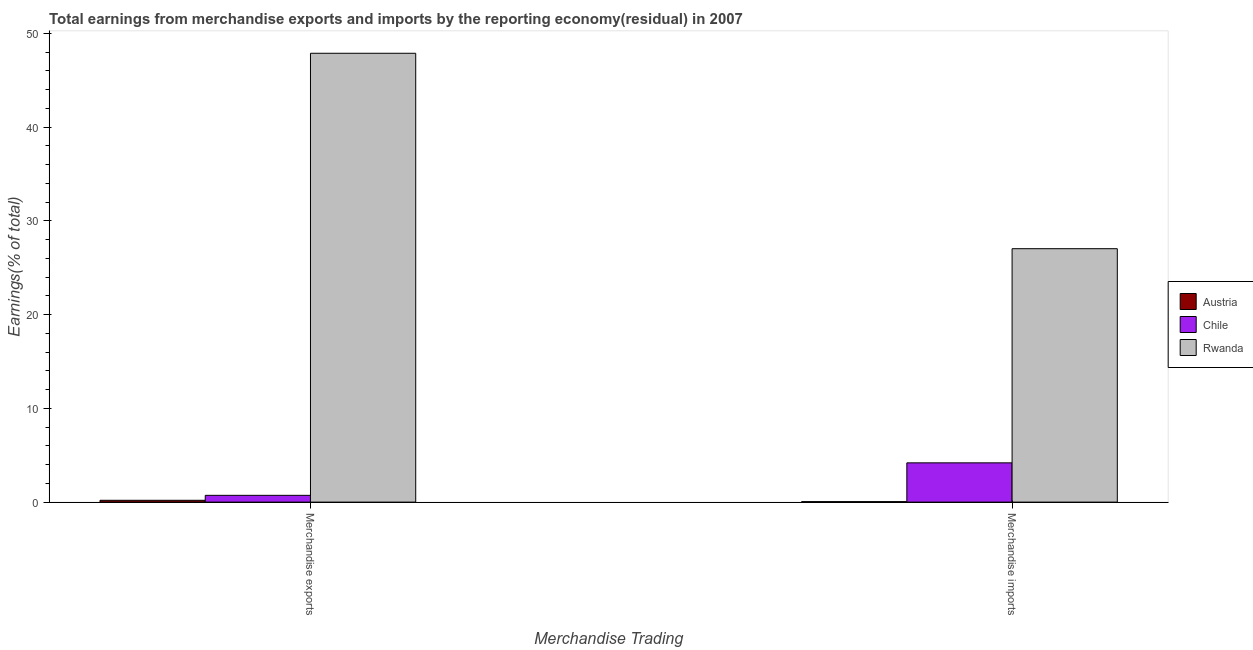How many bars are there on the 2nd tick from the right?
Your answer should be compact. 3. What is the earnings from merchandise imports in Chile?
Offer a terse response. 4.19. Across all countries, what is the maximum earnings from merchandise exports?
Ensure brevity in your answer.  47.87. Across all countries, what is the minimum earnings from merchandise exports?
Keep it short and to the point. 0.2. In which country was the earnings from merchandise imports maximum?
Your answer should be very brief. Rwanda. In which country was the earnings from merchandise imports minimum?
Your answer should be very brief. Austria. What is the total earnings from merchandise exports in the graph?
Offer a terse response. 48.79. What is the difference between the earnings from merchandise exports in Rwanda and that in Chile?
Provide a succinct answer. 47.15. What is the difference between the earnings from merchandise exports in Austria and the earnings from merchandise imports in Rwanda?
Your answer should be compact. -26.83. What is the average earnings from merchandise imports per country?
Provide a short and direct response. 10.42. What is the difference between the earnings from merchandise imports and earnings from merchandise exports in Austria?
Ensure brevity in your answer.  -0.15. In how many countries, is the earnings from merchandise exports greater than 36 %?
Your answer should be compact. 1. What is the ratio of the earnings from merchandise exports in Rwanda to that in Chile?
Offer a terse response. 66.14. In how many countries, is the earnings from merchandise exports greater than the average earnings from merchandise exports taken over all countries?
Offer a terse response. 1. What does the 3rd bar from the left in Merchandise exports represents?
Your response must be concise. Rwanda. How many bars are there?
Provide a short and direct response. 6. Are all the bars in the graph horizontal?
Make the answer very short. No. Does the graph contain grids?
Keep it short and to the point. No. Where does the legend appear in the graph?
Provide a succinct answer. Center right. How are the legend labels stacked?
Make the answer very short. Vertical. What is the title of the graph?
Provide a short and direct response. Total earnings from merchandise exports and imports by the reporting economy(residual) in 2007. Does "Euro area" appear as one of the legend labels in the graph?
Ensure brevity in your answer.  No. What is the label or title of the X-axis?
Give a very brief answer. Merchandise Trading. What is the label or title of the Y-axis?
Offer a terse response. Earnings(% of total). What is the Earnings(% of total) of Austria in Merchandise exports?
Make the answer very short. 0.2. What is the Earnings(% of total) in Chile in Merchandise exports?
Offer a terse response. 0.72. What is the Earnings(% of total) in Rwanda in Merchandise exports?
Your response must be concise. 47.87. What is the Earnings(% of total) in Austria in Merchandise imports?
Offer a terse response. 0.05. What is the Earnings(% of total) of Chile in Merchandise imports?
Provide a succinct answer. 4.19. What is the Earnings(% of total) in Rwanda in Merchandise imports?
Your response must be concise. 27.03. Across all Merchandise Trading, what is the maximum Earnings(% of total) of Austria?
Your answer should be compact. 0.2. Across all Merchandise Trading, what is the maximum Earnings(% of total) in Chile?
Keep it short and to the point. 4.19. Across all Merchandise Trading, what is the maximum Earnings(% of total) of Rwanda?
Ensure brevity in your answer.  47.87. Across all Merchandise Trading, what is the minimum Earnings(% of total) in Austria?
Keep it short and to the point. 0.05. Across all Merchandise Trading, what is the minimum Earnings(% of total) in Chile?
Your response must be concise. 0.72. Across all Merchandise Trading, what is the minimum Earnings(% of total) in Rwanda?
Your response must be concise. 27.03. What is the total Earnings(% of total) in Austria in the graph?
Your response must be concise. 0.25. What is the total Earnings(% of total) in Chile in the graph?
Ensure brevity in your answer.  4.91. What is the total Earnings(% of total) of Rwanda in the graph?
Give a very brief answer. 74.9. What is the difference between the Earnings(% of total) of Austria in Merchandise exports and that in Merchandise imports?
Provide a short and direct response. 0.15. What is the difference between the Earnings(% of total) in Chile in Merchandise exports and that in Merchandise imports?
Provide a short and direct response. -3.47. What is the difference between the Earnings(% of total) in Rwanda in Merchandise exports and that in Merchandise imports?
Offer a very short reply. 20.84. What is the difference between the Earnings(% of total) of Austria in Merchandise exports and the Earnings(% of total) of Chile in Merchandise imports?
Offer a terse response. -3.99. What is the difference between the Earnings(% of total) of Austria in Merchandise exports and the Earnings(% of total) of Rwanda in Merchandise imports?
Make the answer very short. -26.83. What is the difference between the Earnings(% of total) in Chile in Merchandise exports and the Earnings(% of total) in Rwanda in Merchandise imports?
Offer a terse response. -26.3. What is the average Earnings(% of total) in Austria per Merchandise Trading?
Provide a short and direct response. 0.12. What is the average Earnings(% of total) of Chile per Merchandise Trading?
Keep it short and to the point. 2.46. What is the average Earnings(% of total) of Rwanda per Merchandise Trading?
Keep it short and to the point. 37.45. What is the difference between the Earnings(% of total) of Austria and Earnings(% of total) of Chile in Merchandise exports?
Keep it short and to the point. -0.53. What is the difference between the Earnings(% of total) in Austria and Earnings(% of total) in Rwanda in Merchandise exports?
Give a very brief answer. -47.67. What is the difference between the Earnings(% of total) in Chile and Earnings(% of total) in Rwanda in Merchandise exports?
Offer a very short reply. -47.15. What is the difference between the Earnings(% of total) of Austria and Earnings(% of total) of Chile in Merchandise imports?
Your answer should be very brief. -4.14. What is the difference between the Earnings(% of total) in Austria and Earnings(% of total) in Rwanda in Merchandise imports?
Your answer should be very brief. -26.98. What is the difference between the Earnings(% of total) in Chile and Earnings(% of total) in Rwanda in Merchandise imports?
Give a very brief answer. -22.84. What is the ratio of the Earnings(% of total) in Austria in Merchandise exports to that in Merchandise imports?
Provide a short and direct response. 3.87. What is the ratio of the Earnings(% of total) in Chile in Merchandise exports to that in Merchandise imports?
Offer a terse response. 0.17. What is the ratio of the Earnings(% of total) in Rwanda in Merchandise exports to that in Merchandise imports?
Provide a succinct answer. 1.77. What is the difference between the highest and the second highest Earnings(% of total) of Austria?
Make the answer very short. 0.15. What is the difference between the highest and the second highest Earnings(% of total) of Chile?
Keep it short and to the point. 3.47. What is the difference between the highest and the second highest Earnings(% of total) of Rwanda?
Your response must be concise. 20.84. What is the difference between the highest and the lowest Earnings(% of total) in Austria?
Ensure brevity in your answer.  0.15. What is the difference between the highest and the lowest Earnings(% of total) in Chile?
Make the answer very short. 3.47. What is the difference between the highest and the lowest Earnings(% of total) of Rwanda?
Your answer should be compact. 20.84. 